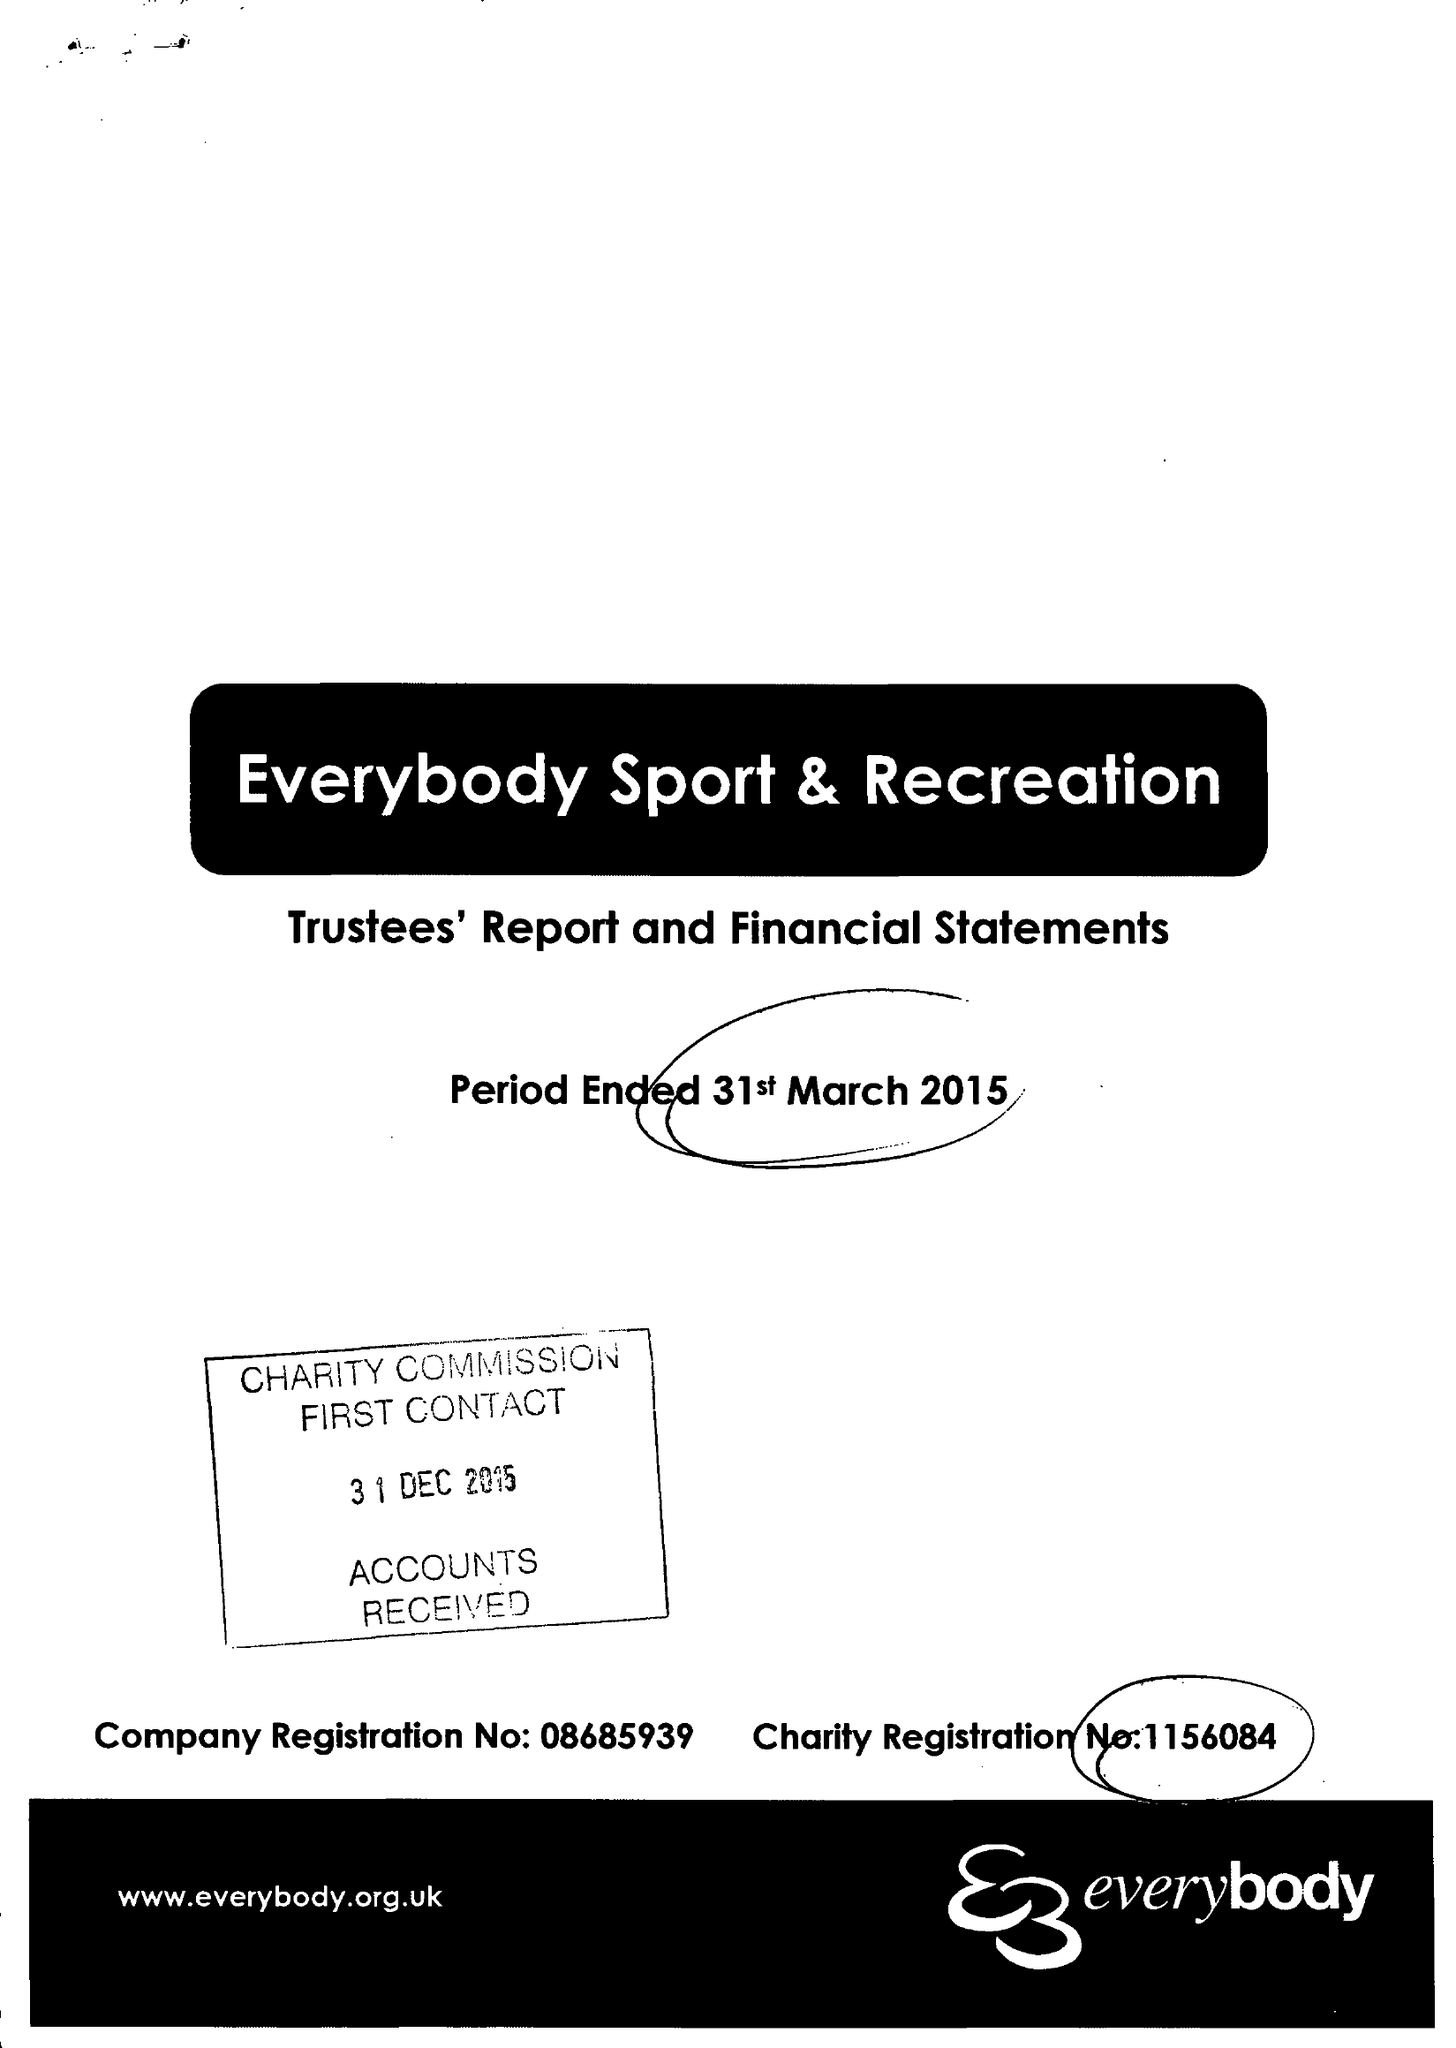What is the value for the charity_name?
Answer the question using a single word or phrase. Everybody Sport and Recreation 